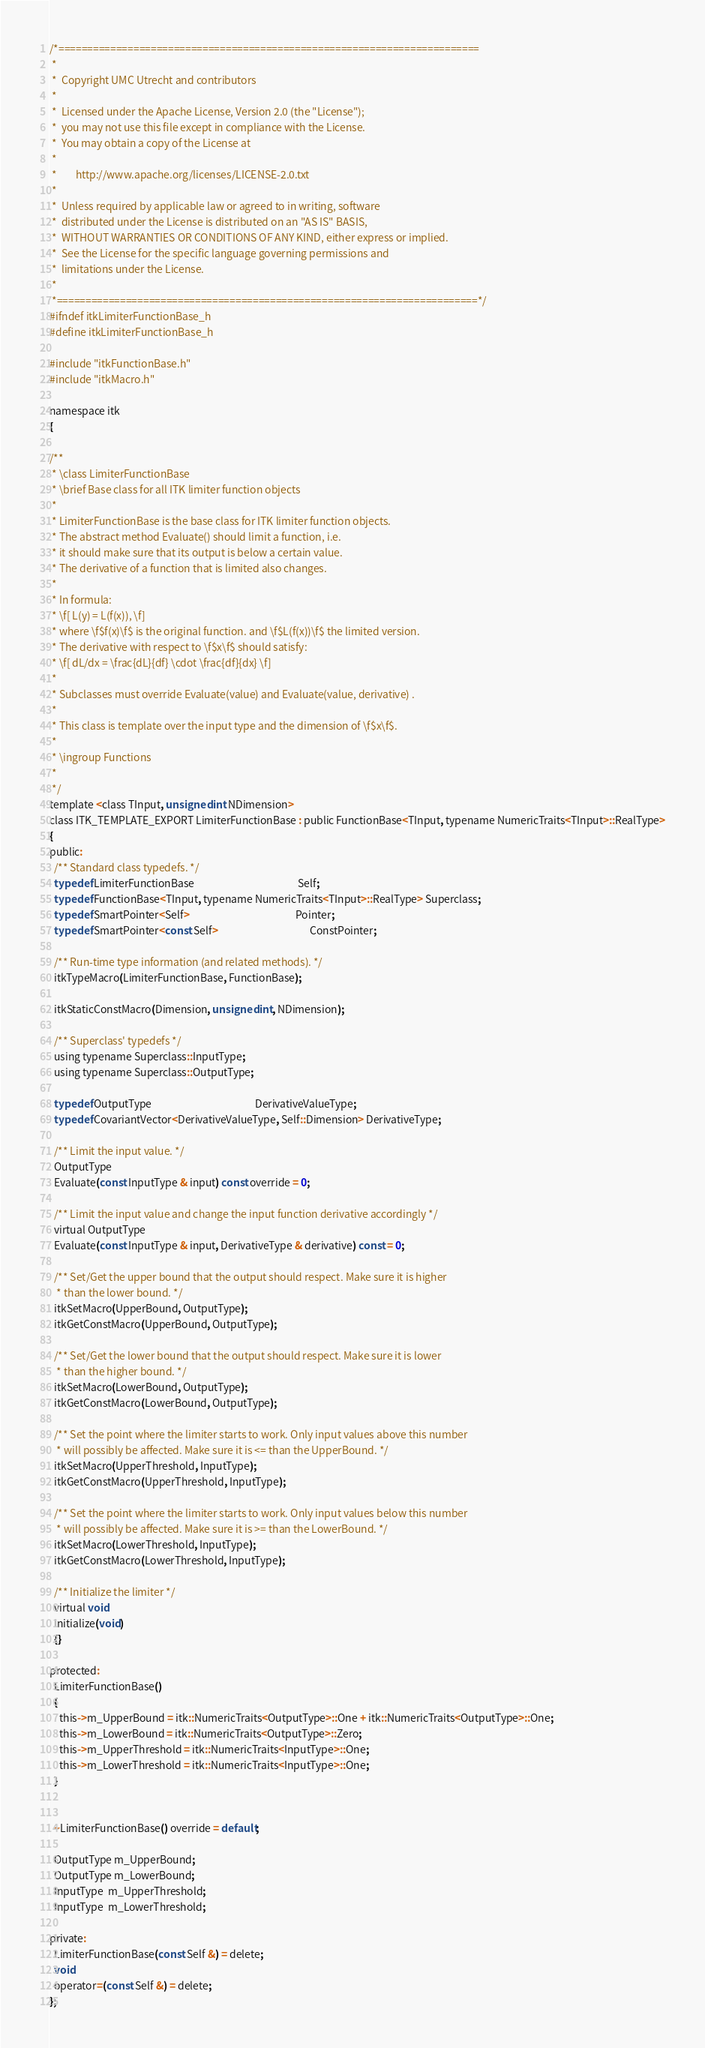Convert code to text. <code><loc_0><loc_0><loc_500><loc_500><_C_>/*=========================================================================
 *
 *  Copyright UMC Utrecht and contributors
 *
 *  Licensed under the Apache License, Version 2.0 (the "License");
 *  you may not use this file except in compliance with the License.
 *  You may obtain a copy of the License at
 *
 *        http://www.apache.org/licenses/LICENSE-2.0.txt
 *
 *  Unless required by applicable law or agreed to in writing, software
 *  distributed under the License is distributed on an "AS IS" BASIS,
 *  WITHOUT WARRANTIES OR CONDITIONS OF ANY KIND, either express or implied.
 *  See the License for the specific language governing permissions and
 *  limitations under the License.
 *
 *=========================================================================*/
#ifndef itkLimiterFunctionBase_h
#define itkLimiterFunctionBase_h

#include "itkFunctionBase.h"
#include "itkMacro.h"

namespace itk
{

/**
 * \class LimiterFunctionBase
 * \brief Base class for all ITK limiter function objects
 *
 * LimiterFunctionBase is the base class for ITK limiter function objects.
 * The abstract method Evaluate() should limit a function, i.e.
 * it should make sure that its output is below a certain value.
 * The derivative of a function that is limited also changes.
 *
 * In formula:
 * \f[ L(y) = L(f(x)), \f]
 * where \f$f(x)\f$ is the original function. and \f$L(f(x))\f$ the limited version.
 * The derivative with respect to \f$x\f$ should satisfy:
 * \f[ dL/dx = \frac{dL}{df} \cdot \frac{df}{dx} \f]
 *
 * Subclasses must override Evaluate(value) and Evaluate(value, derivative) .
 *
 * This class is template over the input type and the dimension of \f$x\f$.
 *
 * \ingroup Functions
 *
 */
template <class TInput, unsigned int NDimension>
class ITK_TEMPLATE_EXPORT LimiterFunctionBase : public FunctionBase<TInput, typename NumericTraits<TInput>::RealType>
{
public:
  /** Standard class typedefs. */
  typedef LimiterFunctionBase                                            Self;
  typedef FunctionBase<TInput, typename NumericTraits<TInput>::RealType> Superclass;
  typedef SmartPointer<Self>                                             Pointer;
  typedef SmartPointer<const Self>                                       ConstPointer;

  /** Run-time type information (and related methods). */
  itkTypeMacro(LimiterFunctionBase, FunctionBase);

  itkStaticConstMacro(Dimension, unsigned int, NDimension);

  /** Superclass' typedefs */
  using typename Superclass::InputType;
  using typename Superclass::OutputType;

  typedef OutputType                                            DerivativeValueType;
  typedef CovariantVector<DerivativeValueType, Self::Dimension> DerivativeType;

  /** Limit the input value. */
  OutputType
  Evaluate(const InputType & input) const override = 0;

  /** Limit the input value and change the input function derivative accordingly */
  virtual OutputType
  Evaluate(const InputType & input, DerivativeType & derivative) const = 0;

  /** Set/Get the upper bound that the output should respect. Make sure it is higher
   * than the lower bound. */
  itkSetMacro(UpperBound, OutputType);
  itkGetConstMacro(UpperBound, OutputType);

  /** Set/Get the lower bound that the output should respect. Make sure it is lower
   * than the higher bound. */
  itkSetMacro(LowerBound, OutputType);
  itkGetConstMacro(LowerBound, OutputType);

  /** Set the point where the limiter starts to work. Only input values above this number
   * will possibly be affected. Make sure it is <= than the UpperBound. */
  itkSetMacro(UpperThreshold, InputType);
  itkGetConstMacro(UpperThreshold, InputType);

  /** Set the point where the limiter starts to work. Only input values below this number
   * will possibly be affected. Make sure it is >= than the LowerBound. */
  itkSetMacro(LowerThreshold, InputType);
  itkGetConstMacro(LowerThreshold, InputType);

  /** Initialize the limiter */
  virtual void
  Initialize(void)
  {}

protected:
  LimiterFunctionBase()
  {
    this->m_UpperBound = itk::NumericTraits<OutputType>::One + itk::NumericTraits<OutputType>::One;
    this->m_LowerBound = itk::NumericTraits<OutputType>::Zero;
    this->m_UpperThreshold = itk::NumericTraits<InputType>::One;
    this->m_LowerThreshold = itk::NumericTraits<InputType>::One;
  }


  ~LimiterFunctionBase() override = default;

  OutputType m_UpperBound;
  OutputType m_LowerBound;
  InputType  m_UpperThreshold;
  InputType  m_LowerThreshold;

private:
  LimiterFunctionBase(const Self &) = delete;
  void
  operator=(const Self &) = delete;
};
</code> 